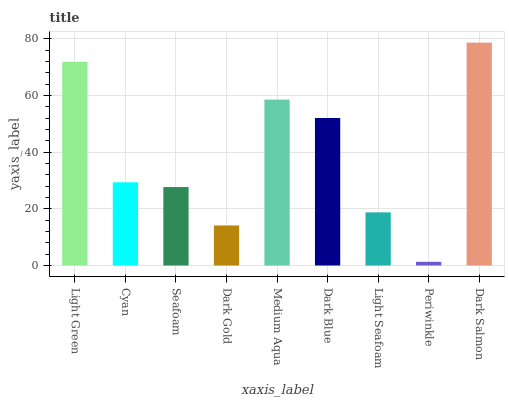Is Periwinkle the minimum?
Answer yes or no. Yes. Is Dark Salmon the maximum?
Answer yes or no. Yes. Is Cyan the minimum?
Answer yes or no. No. Is Cyan the maximum?
Answer yes or no. No. Is Light Green greater than Cyan?
Answer yes or no. Yes. Is Cyan less than Light Green?
Answer yes or no. Yes. Is Cyan greater than Light Green?
Answer yes or no. No. Is Light Green less than Cyan?
Answer yes or no. No. Is Cyan the high median?
Answer yes or no. Yes. Is Cyan the low median?
Answer yes or no. Yes. Is Medium Aqua the high median?
Answer yes or no. No. Is Seafoam the low median?
Answer yes or no. No. 